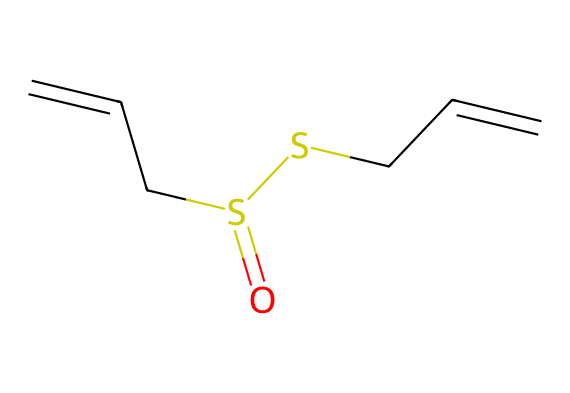What is the molecular formula of allicin? To determine the molecular formula, we count the number of each type of atom in the SMILES representation. The SMILES C=CCS(=O)SCC=C represents 6 carbon (C), 10 hydrogen (H), and 2 sulfur (S) atoms. Therefore, the molecular formula is C6H10S2.
Answer: C6H10S2 How many double bonds are present in this structure? By examining the SMILES notation, we can identify the connections. The double bond indicated by "=" appears twice, once between the first two carbon atoms and once between the last two carbon atoms. Thus, there are two double bonds in total.
Answer: 2 What type of functional groups are present in allicin? The SMILES shows the presence of a sulfonyl (S=O) and a thiol (S). These functional groups are distinctive to organosulfur compounds and contribute to the properties of allicin.
Answer: sulfonyl and thiol What is the significance of the sulfur atoms in allicin? The sulfur atoms contribute to the unique properties that give garlic its characteristic flavor and potential health benefits. Their presence is crucial for the compound's biological activity and its strong odor.
Answer: unique properties Does allicin contain rings or chains in its structure? Upon analyzing the SMILES notation, we observe that allicin has a chain structure with no rings present. The carbon atoms are connected in a linear fashion with double bonds, indicating that it is an acyclic compound.
Answer: chains How many total atoms are in allicin? To find the total atom count, we sum the counts of each type of atom derived from the molecular formula: 6 carbon + 10 hydrogen + 2 sulfur equals 18 atoms in total.
Answer: 18 